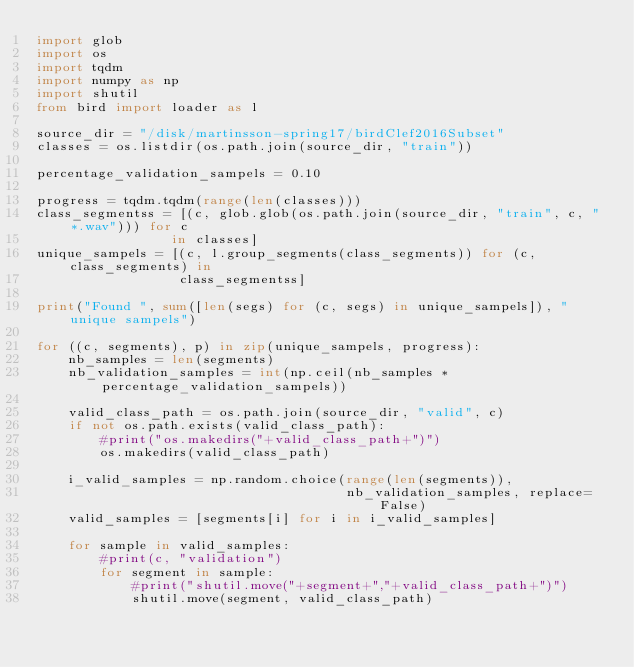Convert code to text. <code><loc_0><loc_0><loc_500><loc_500><_Python_>import glob
import os
import tqdm
import numpy as np
import shutil
from bird import loader as l

source_dir = "/disk/martinsson-spring17/birdClef2016Subset"
classes = os.listdir(os.path.join(source_dir, "train"))

percentage_validation_sampels = 0.10

progress = tqdm.tqdm(range(len(classes)))
class_segmentss = [(c, glob.glob(os.path.join(source_dir, "train", c, "*.wav"))) for c
                 in classes]
unique_sampels = [(c, l.group_segments(class_segments)) for (c, class_segments) in
                  class_segmentss]

print("Found ", sum([len(segs) for (c, segs) in unique_sampels]), " unique sampels")

for ((c, segments), p) in zip(unique_sampels, progress):
    nb_samples = len(segments)
    nb_validation_samples = int(np.ceil(nb_samples * percentage_validation_sampels))

    valid_class_path = os.path.join(source_dir, "valid", c)
    if not os.path.exists(valid_class_path):
        #print("os.makedirs("+valid_class_path+")")
        os.makedirs(valid_class_path)

    i_valid_samples = np.random.choice(range(len(segments)),
                                       nb_validation_samples, replace=False)
    valid_samples = [segments[i] for i in i_valid_samples]

    for sample in valid_samples:
        #print(c, "validation")
        for segment in sample:
            #print("shutil.move("+segment+","+valid_class_path+")")
            shutil.move(segment, valid_class_path)
</code> 